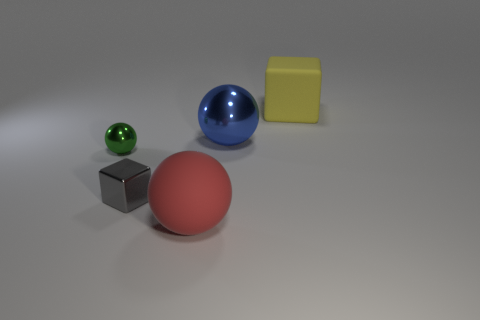How many objects are cyan blocks or cubes that are on the right side of the red matte ball?
Keep it short and to the point. 1. What color is the large matte thing on the left side of the thing behind the big sphere to the right of the large red matte thing?
Offer a terse response. Red. There is a metal ball in front of the big blue ball; how big is it?
Provide a succinct answer. Small. What number of small objects are yellow matte blocks or yellow balls?
Provide a succinct answer. 0. There is a sphere that is behind the big red matte thing and in front of the blue metal object; what is its color?
Your answer should be compact. Green. Is there a big red object of the same shape as the tiny green thing?
Offer a terse response. Yes. What is the material of the large blue ball?
Your answer should be compact. Metal. Are there any large metal objects behind the large rubber ball?
Your response must be concise. Yes. Does the red thing have the same shape as the yellow object?
Give a very brief answer. No. How many other objects are the same size as the red matte thing?
Make the answer very short. 2. 